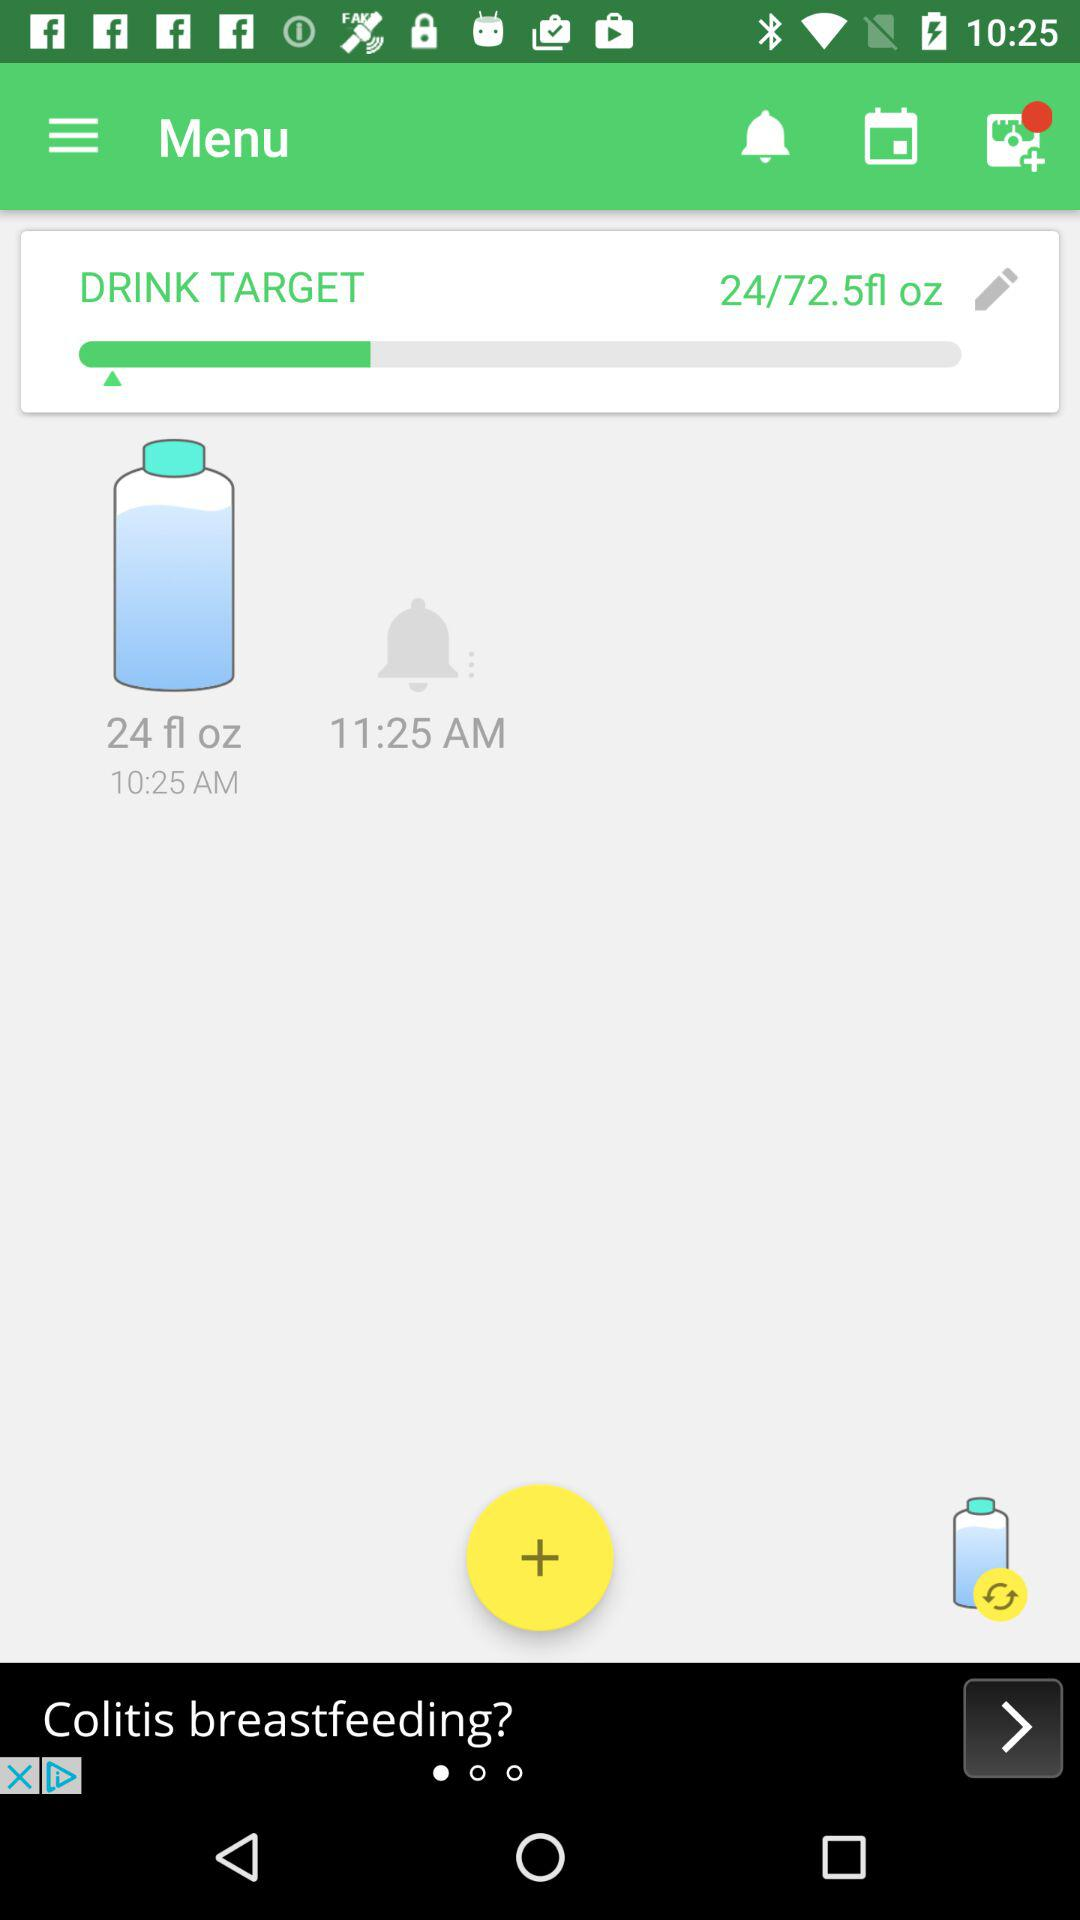How many more ounces do I need to drink?
Answer the question using a single word or phrase. 48.5 